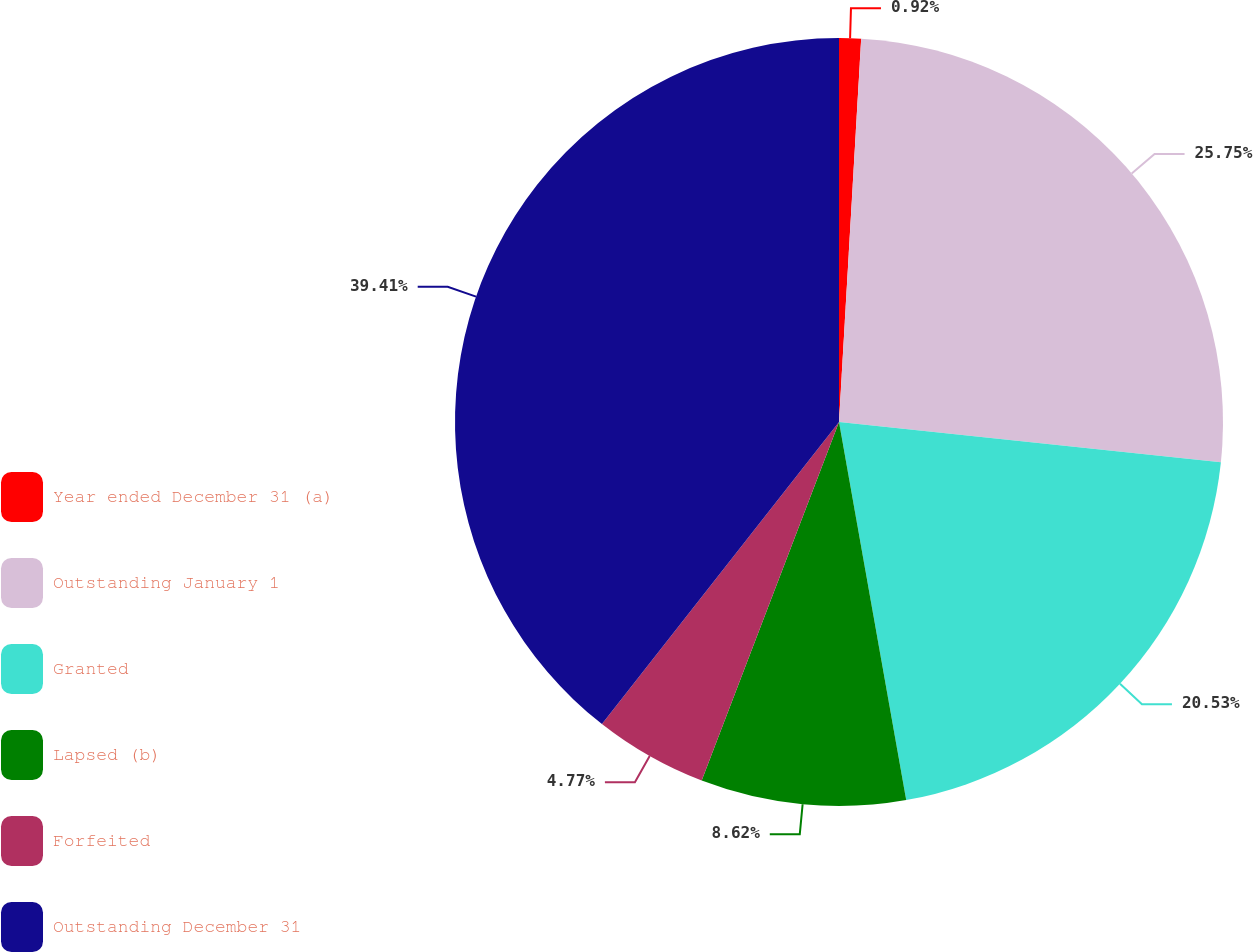<chart> <loc_0><loc_0><loc_500><loc_500><pie_chart><fcel>Year ended December 31 (a)<fcel>Outstanding January 1<fcel>Granted<fcel>Lapsed (b)<fcel>Forfeited<fcel>Outstanding December 31<nl><fcel>0.92%<fcel>25.75%<fcel>20.53%<fcel>8.62%<fcel>4.77%<fcel>39.41%<nl></chart> 